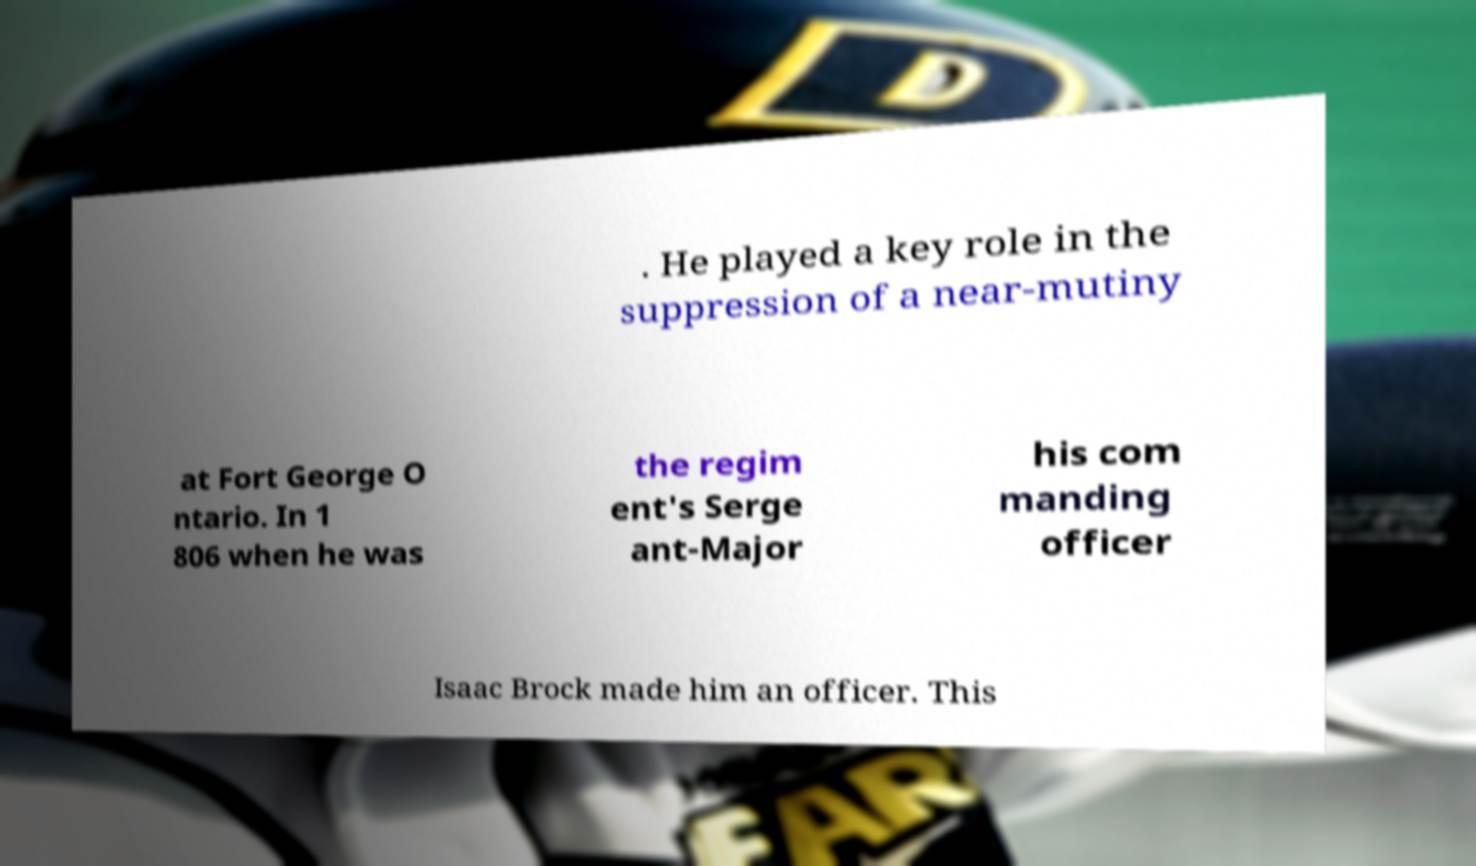Could you assist in decoding the text presented in this image and type it out clearly? . He played a key role in the suppression of a near-mutiny at Fort George O ntario. In 1 806 when he was the regim ent's Serge ant-Major his com manding officer Isaac Brock made him an officer. This 